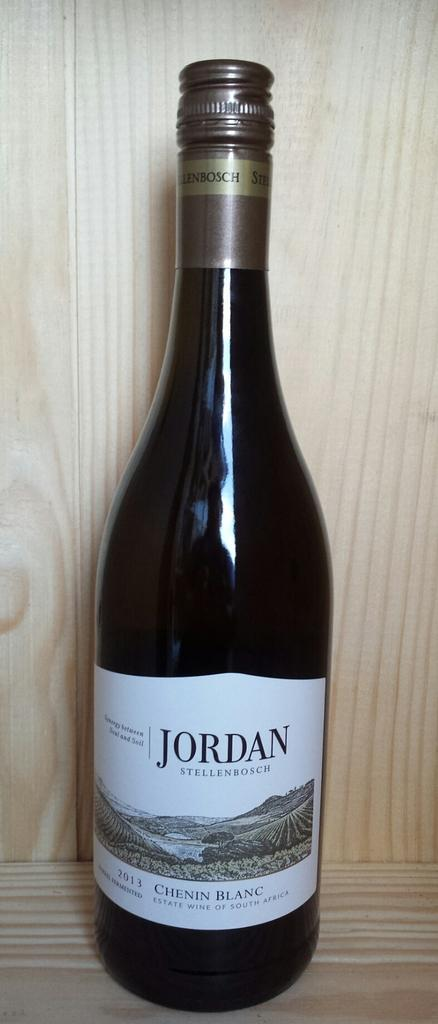<image>
Create a compact narrative representing the image presented. A bottle of Jordan 2011 chenin blanc.sits against a wood wall. 